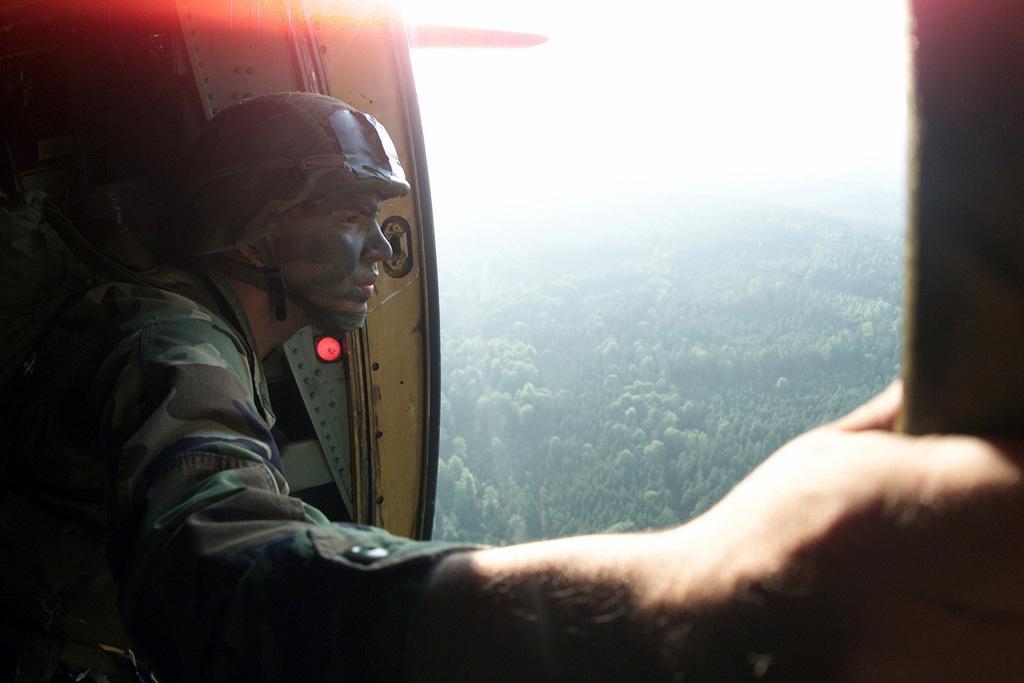Describe this image in one or two sentences. This person wore military dress and helmet. Here we can see trees. 